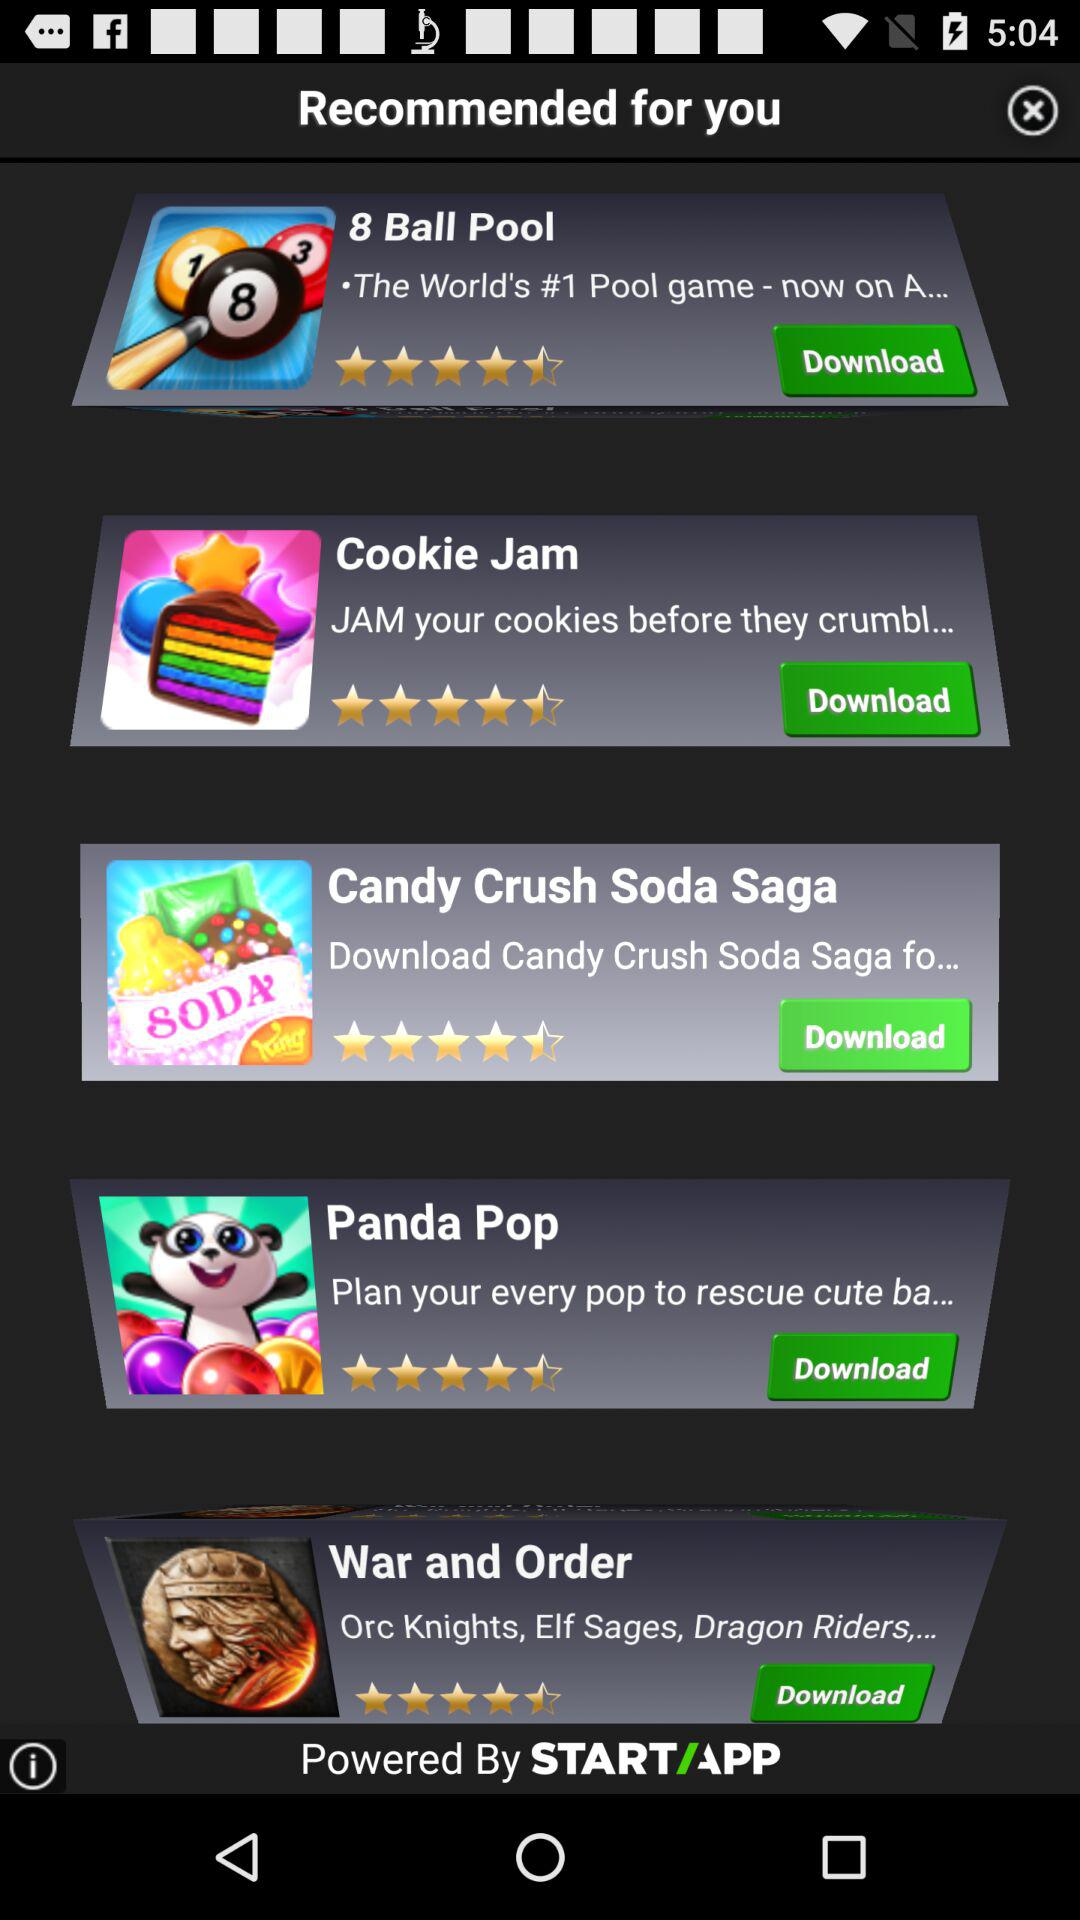What is the star rating for the "8 Ball Pool"? The rating is 4.5 stars. 